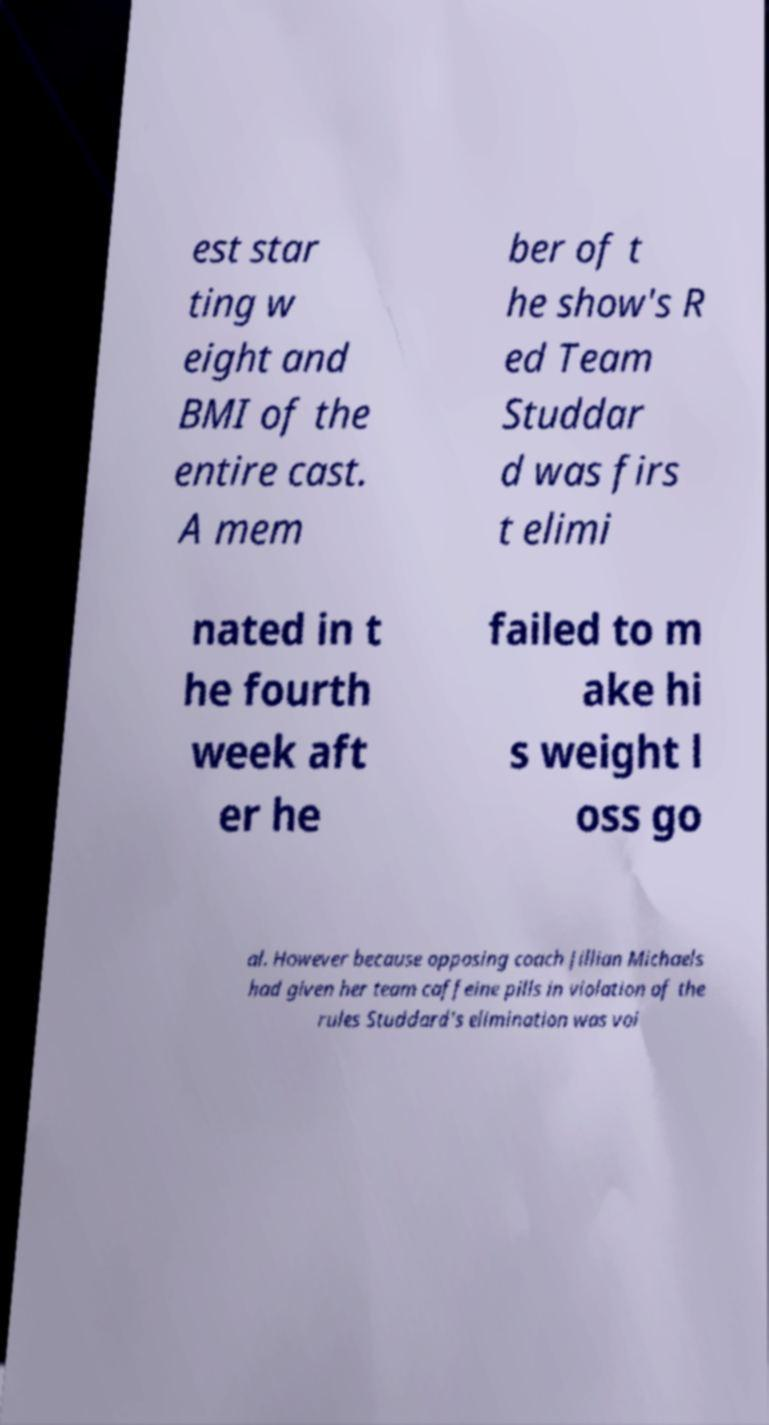Can you read and provide the text displayed in the image?This photo seems to have some interesting text. Can you extract and type it out for me? est star ting w eight and BMI of the entire cast. A mem ber of t he show's R ed Team Studdar d was firs t elimi nated in t he fourth week aft er he failed to m ake hi s weight l oss go al. However because opposing coach Jillian Michaels had given her team caffeine pills in violation of the rules Studdard's elimination was voi 